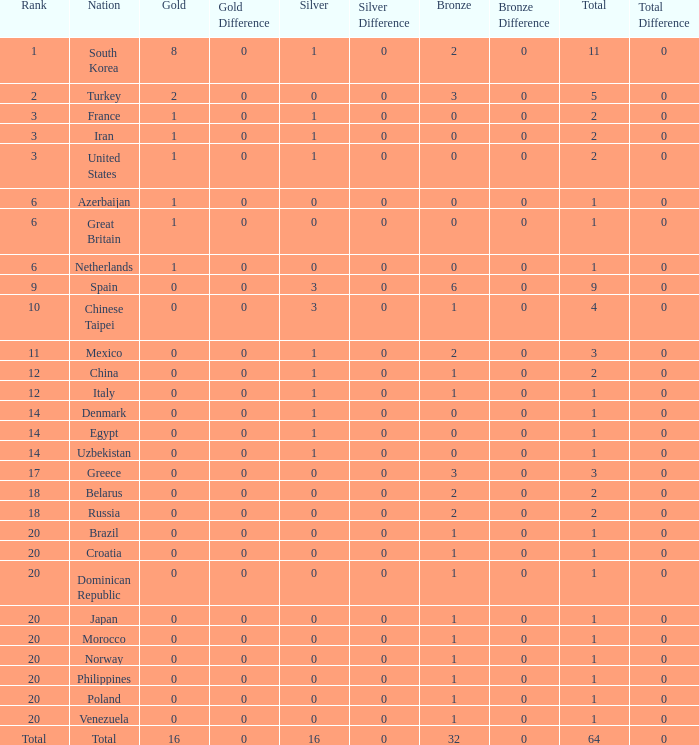What is the lowest number of gold medals the nation with less than 0 silver medals has? None. 